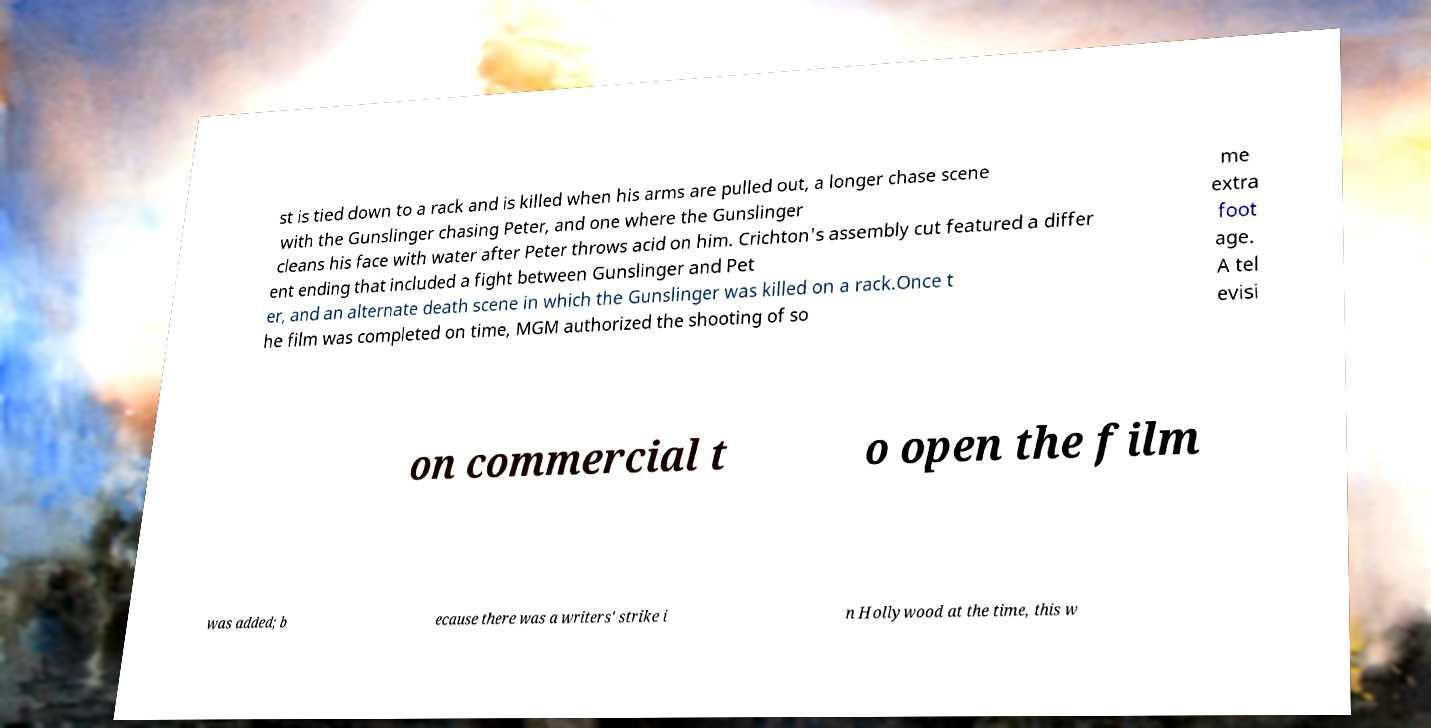Could you extract and type out the text from this image? st is tied down to a rack and is killed when his arms are pulled out, a longer chase scene with the Gunslinger chasing Peter, and one where the Gunslinger cleans his face with water after Peter throws acid on him. Crichton's assembly cut featured a differ ent ending that included a fight between Gunslinger and Pet er, and an alternate death scene in which the Gunslinger was killed on a rack.Once t he film was completed on time, MGM authorized the shooting of so me extra foot age. A tel evisi on commercial t o open the film was added; b ecause there was a writers' strike i n Hollywood at the time, this w 